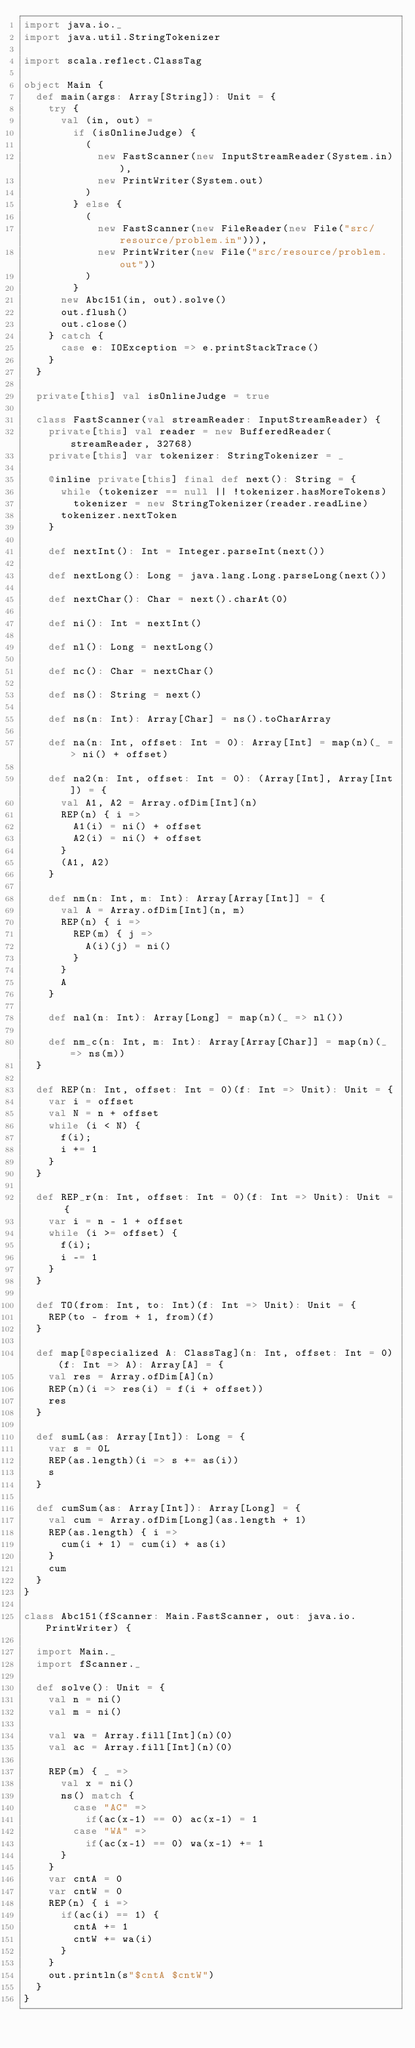<code> <loc_0><loc_0><loc_500><loc_500><_Scala_>import java.io._
import java.util.StringTokenizer

import scala.reflect.ClassTag

object Main {
  def main(args: Array[String]): Unit = {
    try {
      val (in, out) =
        if (isOnlineJudge) {
          (
            new FastScanner(new InputStreamReader(System.in)),
            new PrintWriter(System.out)
          )
        } else {
          (
            new FastScanner(new FileReader(new File("src/resource/problem.in"))),
            new PrintWriter(new File("src/resource/problem.out"))
          )
        }
      new Abc151(in, out).solve()
      out.flush()
      out.close()
    } catch {
      case e: IOException => e.printStackTrace()
    }
  }

  private[this] val isOnlineJudge = true

  class FastScanner(val streamReader: InputStreamReader) {
    private[this] val reader = new BufferedReader(streamReader, 32768)
    private[this] var tokenizer: StringTokenizer = _

    @inline private[this] final def next(): String = {
      while (tokenizer == null || !tokenizer.hasMoreTokens)
        tokenizer = new StringTokenizer(reader.readLine)
      tokenizer.nextToken
    }

    def nextInt(): Int = Integer.parseInt(next())

    def nextLong(): Long = java.lang.Long.parseLong(next())

    def nextChar(): Char = next().charAt(0)

    def ni(): Int = nextInt()

    def nl(): Long = nextLong()

    def nc(): Char = nextChar()

    def ns(): String = next()

    def ns(n: Int): Array[Char] = ns().toCharArray

    def na(n: Int, offset: Int = 0): Array[Int] = map(n)(_ => ni() + offset)

    def na2(n: Int, offset: Int = 0): (Array[Int], Array[Int]) = {
      val A1, A2 = Array.ofDim[Int](n)
      REP(n) { i =>
        A1(i) = ni() + offset
        A2(i) = ni() + offset
      }
      (A1, A2)
    }

    def nm(n: Int, m: Int): Array[Array[Int]] = {
      val A = Array.ofDim[Int](n, m)
      REP(n) { i =>
        REP(m) { j =>
          A(i)(j) = ni()
        }
      }
      A
    }

    def nal(n: Int): Array[Long] = map(n)(_ => nl())

    def nm_c(n: Int, m: Int): Array[Array[Char]] = map(n)(_ => ns(m))
  }

  def REP(n: Int, offset: Int = 0)(f: Int => Unit): Unit = {
    var i = offset
    val N = n + offset
    while (i < N) {
      f(i);
      i += 1
    }
  }

  def REP_r(n: Int, offset: Int = 0)(f: Int => Unit): Unit = {
    var i = n - 1 + offset
    while (i >= offset) {
      f(i);
      i -= 1
    }
  }

  def TO(from: Int, to: Int)(f: Int => Unit): Unit = {
    REP(to - from + 1, from)(f)
  }

  def map[@specialized A: ClassTag](n: Int, offset: Int = 0)(f: Int => A): Array[A] = {
    val res = Array.ofDim[A](n)
    REP(n)(i => res(i) = f(i + offset))
    res
  }

  def sumL(as: Array[Int]): Long = {
    var s = 0L
    REP(as.length)(i => s += as(i))
    s
  }

  def cumSum(as: Array[Int]): Array[Long] = {
    val cum = Array.ofDim[Long](as.length + 1)
    REP(as.length) { i =>
      cum(i + 1) = cum(i) + as(i)
    }
    cum
  }
}

class Abc151(fScanner: Main.FastScanner, out: java.io.PrintWriter) {

  import Main._
  import fScanner._

  def solve(): Unit = {
    val n = ni()
    val m = ni()

    val wa = Array.fill[Int](n)(0)
    val ac = Array.fill[Int](n)(0)

    REP(m) { _ =>
      val x = ni()
      ns() match {
        case "AC" =>
          if(ac(x-1) == 0) ac(x-1) = 1
        case "WA" =>
          if(ac(x-1) == 0) wa(x-1) += 1
      }
    }
    var cntA = 0
    var cntW = 0
    REP(n) { i =>
      if(ac(i) == 1) {
        cntA += 1
        cntW += wa(i)
      }
    }
    out.println(s"$cntA $cntW")
  }
}
</code> 